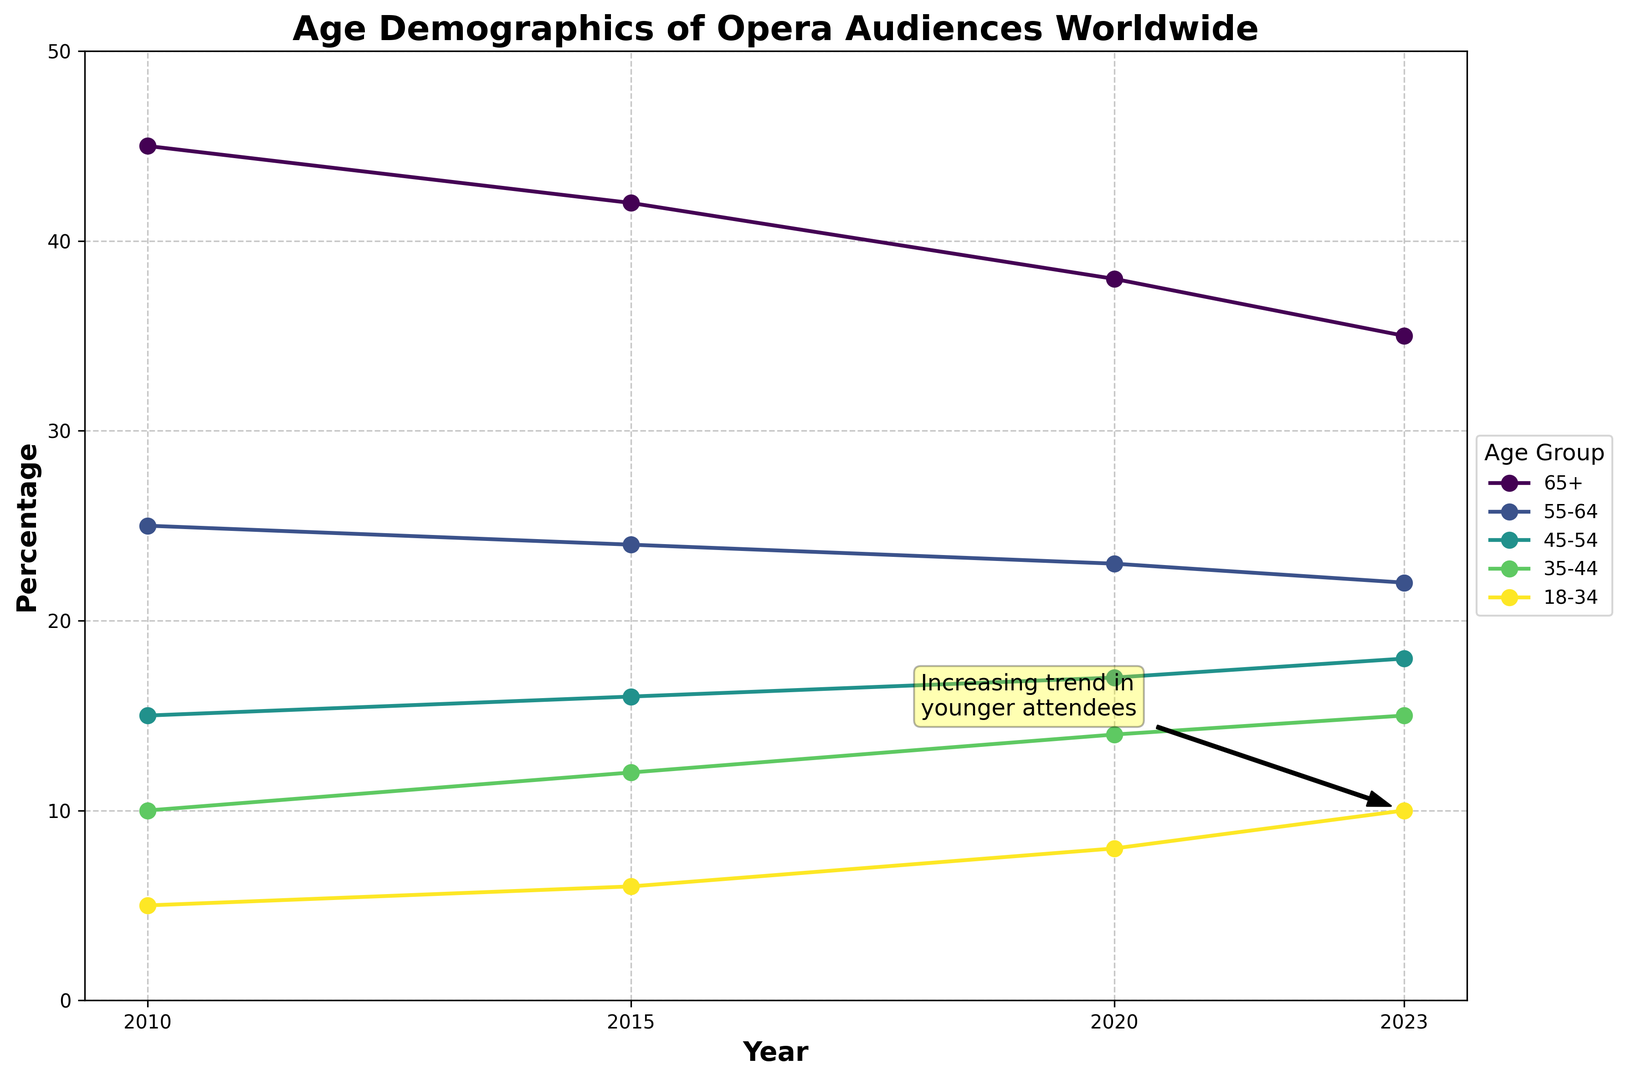Which age group had the highest percentage of opera audience in 2010? To find this, we look at the highest point on the chart for the year 2010. The highest point is for the 65+ age group.
Answer: 65+ What is the percentage increase of the 18-34 age group from 2010 to 2023? To find the percentage increase, we calculate the difference between the 2023 and 2010 values, then divide by the 2010 value, and multiply by 100. So, (10 - 5) / 5 * 100% = 100% increase.
Answer: 100% Compare the trends of the 35-44 and 65+ age groups from 2010 to 2023. Which one shows a decreasing trend? The 65+ age group shows a decreasing trend from 45% in 2010 to 35% in 2023. The 35-44 age group shows an increasing trend from 10% in 2010 to 15% in 2023.
Answer: 65+ How did the percentage for the 55-64 age group change between 2010 and 2023? To determine the change, we find the percentages for 2010 and 2023, and calculate the difference. It decreased from 25% in 2010 to 22% in 2023, a reduction of 3%.
Answer: decreased by 3% What is the average percentage of the 18-34 age group across all years? The percentages for 18-34 are 5%, 6%, 8%, and 10% for the years 2010, 2015, 2020, and 2023. The mean is calculated as (5 + 6 + 8 + 10) / 4 = 7.25%.
Answer: 7.25% Identify the age group with the most significant overall percentage change from 2010 to 2023. This requires calculating the overall change for all age groups. The 18-34 group changes from 5% to 10%, a 5% increase. The 35-44 group changes from 10% to 15%, a 5% increase. The 45-54 group changes from 15% to 18%, a 3% increase. The 55-64 group changes from 25% to 22%, a 3% decrease. The 65+ group changes from 45% to 35%, a 10% decrease. The 65+ group has the most significant change.
Answer: 65+ Which age group does the annotation 'Increasing trend in younger attendees' refer to? The annotation points to the 18-34 age group, highlighting its increasing trend.
Answer: 18-34 